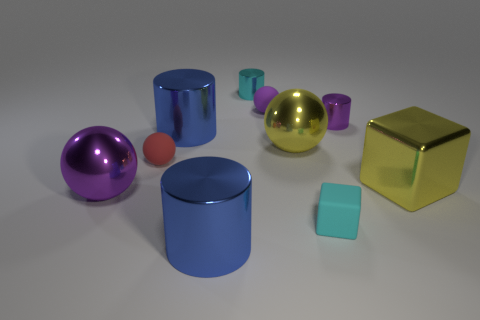Subtract all cylinders. How many objects are left? 6 Subtract all small gray metal cubes. Subtract all big purple things. How many objects are left? 9 Add 2 big metallic cylinders. How many big metallic cylinders are left? 4 Add 5 tiny objects. How many tiny objects exist? 10 Subtract 0 green cylinders. How many objects are left? 10 